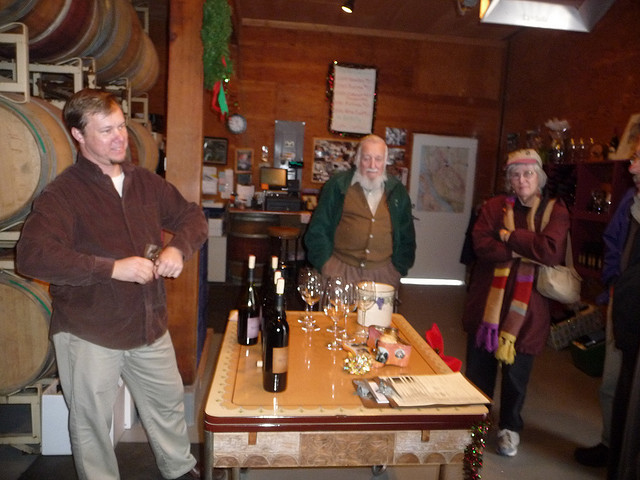<image>What kind of uniform is the lady wearing? It is ambiguous what kind of uniform the lady is wearing. There are suggestions of 'hippie', 'street clothes', 'winter gear', 'waitress', 'scarf' or 'none'. What kind of uniform is the lady wearing? I am not sure what kind of uniform the lady is wearing. It can be seen as 'hippie', 'winter gear', 'street clothes', 'indian', 'waitress' or 'scarf'. 